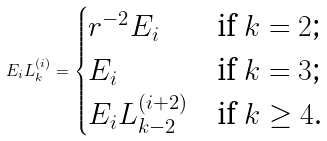<formula> <loc_0><loc_0><loc_500><loc_500>E _ { i } L _ { k } ^ { ( i ) } = \begin{cases} r ^ { - 2 } E _ { i } & \text {if $k=2$;} \\ E _ { i } & \text {if $k=3$;} \\ E _ { i } L _ { k - 2 } ^ { ( i + 2 ) } & \text {if $k\geq 4$.} \end{cases}</formula> 